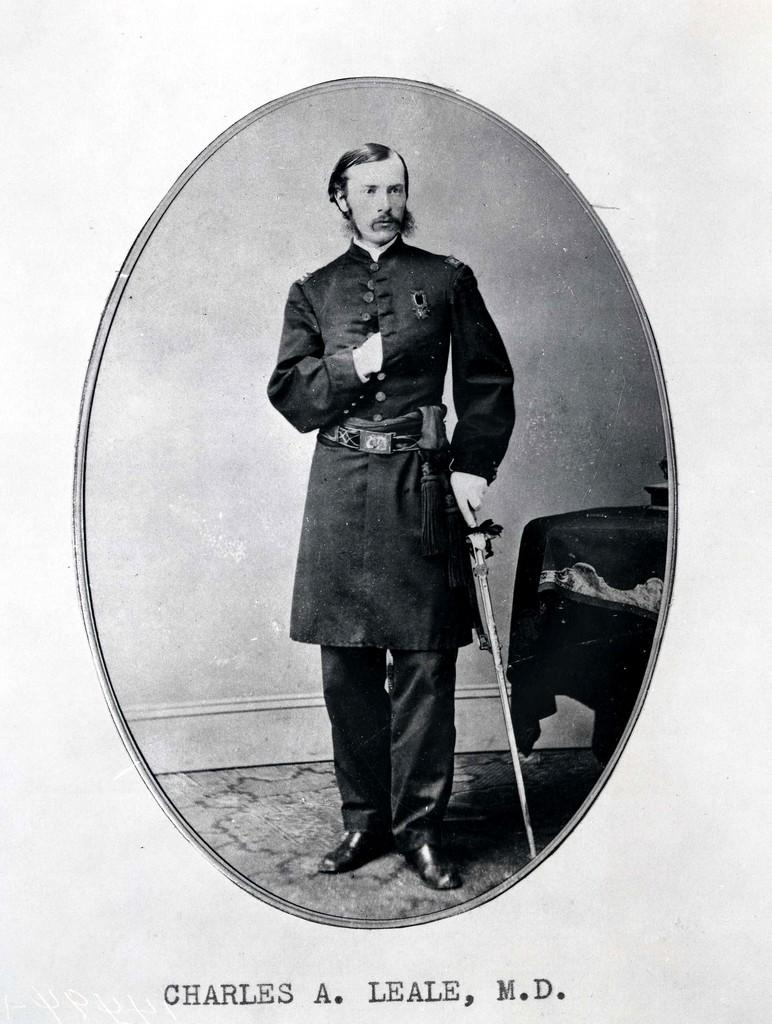What type of art is depicted in the image? The image is a paper cutting. What is the man in the image doing? The man is holding a stick in the image. What is the position of the man in the image? The man is standing in the image. What type of furniture is present in the image? There is a chair in the image. What additional information can be found at the bottom of the image? There is text at the bottom of the image. How many ants can be seen crawling on the chair in the image? There are no ants present in the image; it only features a man holding a stick, a chair, and text at the bottom. 